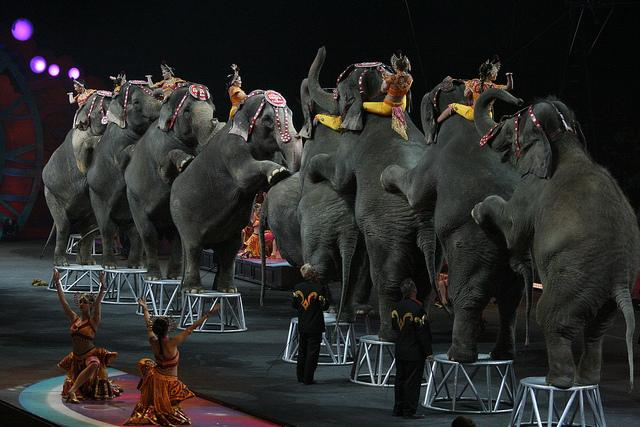What are the elephants doing?

Choices:
A) foraging
B) performing
C) mating
D) stampeding performing 